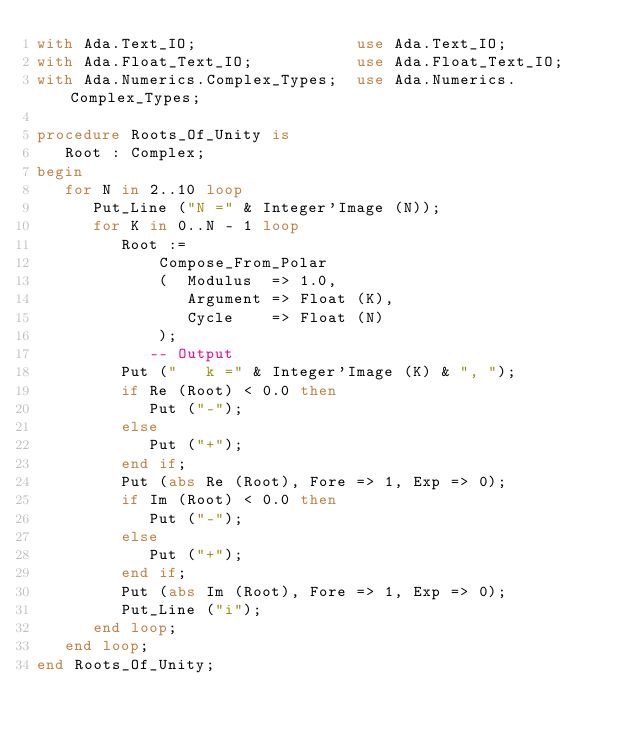<code> <loc_0><loc_0><loc_500><loc_500><_Ada_>with Ada.Text_IO;                 use Ada.Text_IO;
with Ada.Float_Text_IO;           use Ada.Float_Text_IO;
with Ada.Numerics.Complex_Types;  use Ada.Numerics.Complex_Types;

procedure Roots_Of_Unity is
   Root : Complex;
begin
   for N in 2..10 loop
      Put_Line ("N =" & Integer'Image (N));
      for K in 0..N - 1 loop
         Root :=
             Compose_From_Polar
             (  Modulus  => 1.0,
                Argument => Float (K),
                Cycle    => Float (N)
             );
            -- Output
         Put ("   k =" & Integer'Image (K) & ", ");
         if Re (Root) < 0.0 then
            Put ("-");
         else
            Put ("+");
         end if;
         Put (abs Re (Root), Fore => 1, Exp => 0);
         if Im (Root) < 0.0 then
            Put ("-");
         else
            Put ("+");
         end if;
         Put (abs Im (Root), Fore => 1, Exp => 0);
         Put_Line ("i");
      end loop;
   end loop;
end Roots_Of_Unity;
</code> 